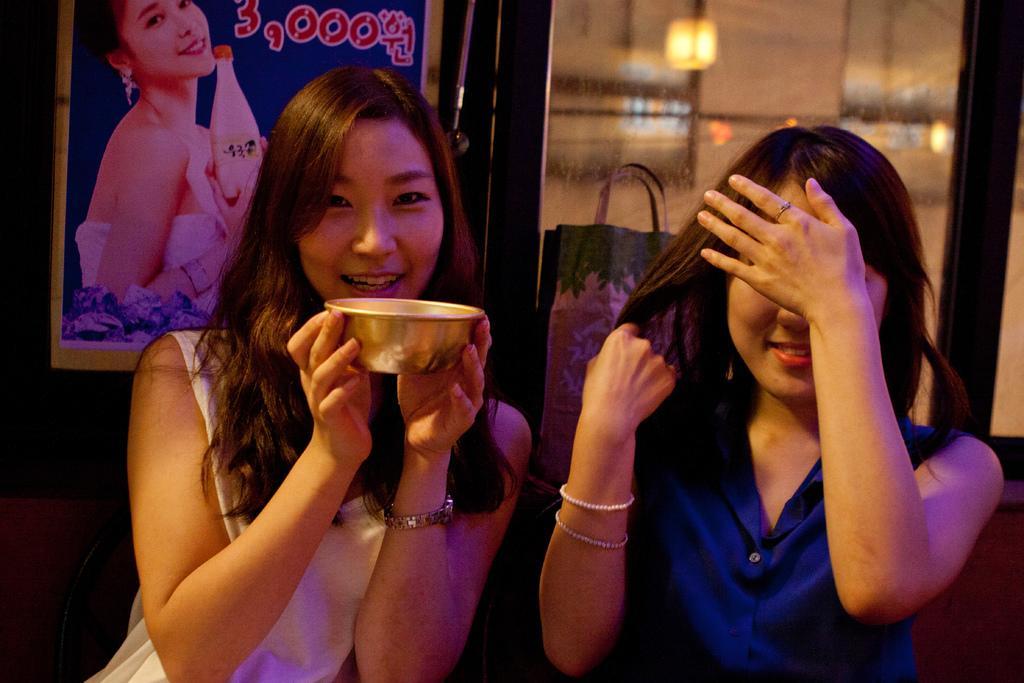Can you describe this image briefly? In the center of the image we can see two ladies are sitting and a lady is holding a bowl. In the background of the image we can see a board on the wall, glass door. Through the glass door, we can see a bag, floor, lights, pillar and wall. 